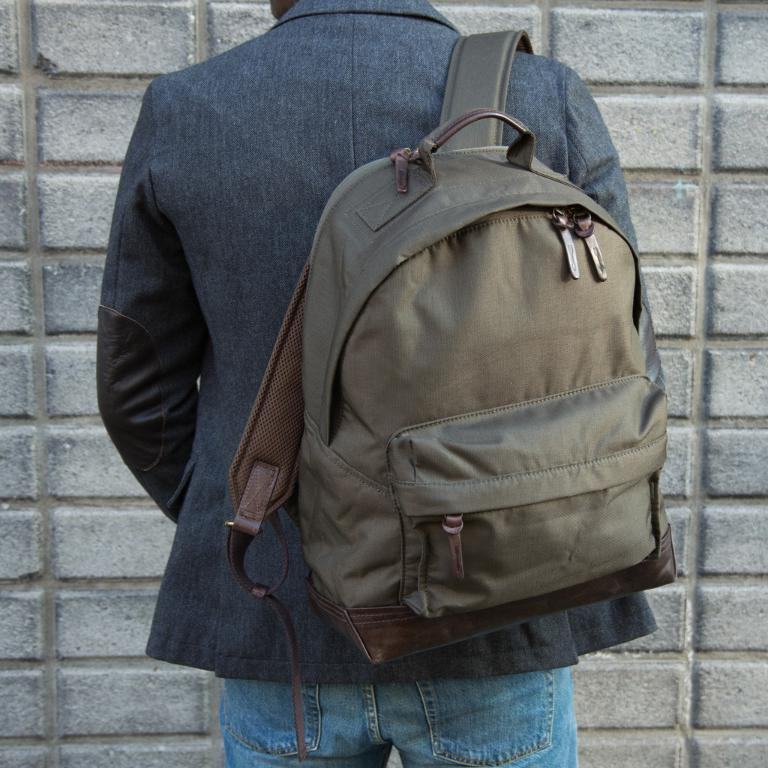Who is present in the image? There is a man in the image. What is the man wearing? The man is wearing a black jacket. What is the man carrying in the image? The man is carrying a bag. What type of canvas is the man painting on in the image? There is no canvas or painting activity present in the image. 